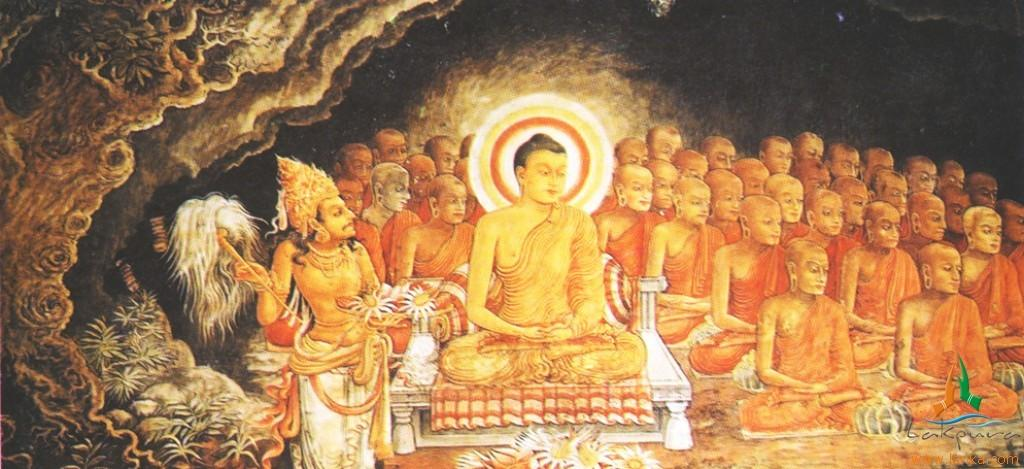What are the people in the image wearing? The persons in the image are wearing clothes. Can you describe the position of one of the persons in the image? There is a person sitting on a bench in the middle of the image. What type of sack can be seen in the image? There is no sack present in the image. Is the existence of zinc confirmed in the image? There is no mention of zinc in the image, so its existence cannot be confirmed. 